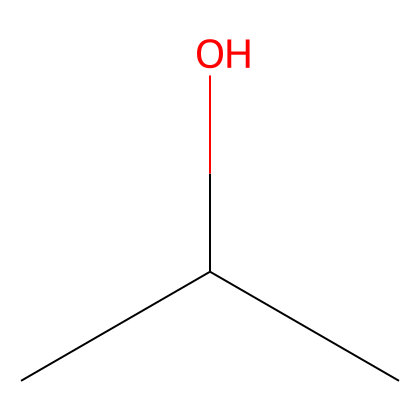What is the name of this chemical? The chemical is represented by the SMILES notation CC(C)O, which corresponds to isopropyl alcohol, a common flammable liquid.
Answer: isopropyl alcohol How many carbon atoms are in this chemical? By examining the SMILES notation CC(C)O, we can see that there are three carbon (C) atoms that are part of the structure, indicated by the three "C" characters.
Answer: 3 What type of alcohol is this chemical? Isopropyl alcohol, as indicated by the alcohol functional group (the -OH), is classified as a secondary alcohol because the hydroxyl group is attached to a carbon that is connected to two other carbons.
Answer: secondary What is the functional group present in this chemical? The SMILES notation includes an "O" at the end, indicating that it has a hydroxyl group (-OH), which is characteristic of alcohols.
Answer: hydroxyl group What is the flash point of isopropyl alcohol? The flash point of isopropyl alcohol, a significant property in safety and handling, is around 12 °C, which is identified from various chemical safety data sources.
Answer: 12 °C Why is isopropyl alcohol effective for disinfection? Isopropyl alcohol is effective for disinfection because it can denature proteins and disrupt cell membranes, which are essential for microbial survival and replication. This is due to its molecular structure that allows it to interact efficiently with microbial cell surfaces.
Answer: denatures proteins How does isopropyl alcohol relate to sanitization protocols? Isopropyl alcohol is a key component in sanitization protocols as it effectively kills a broad spectrum of bacteria and viruses, making it suitable for hand sanitizers and surface disinfectants, as indicated by its common use in healthcare settings.
Answer: key component 